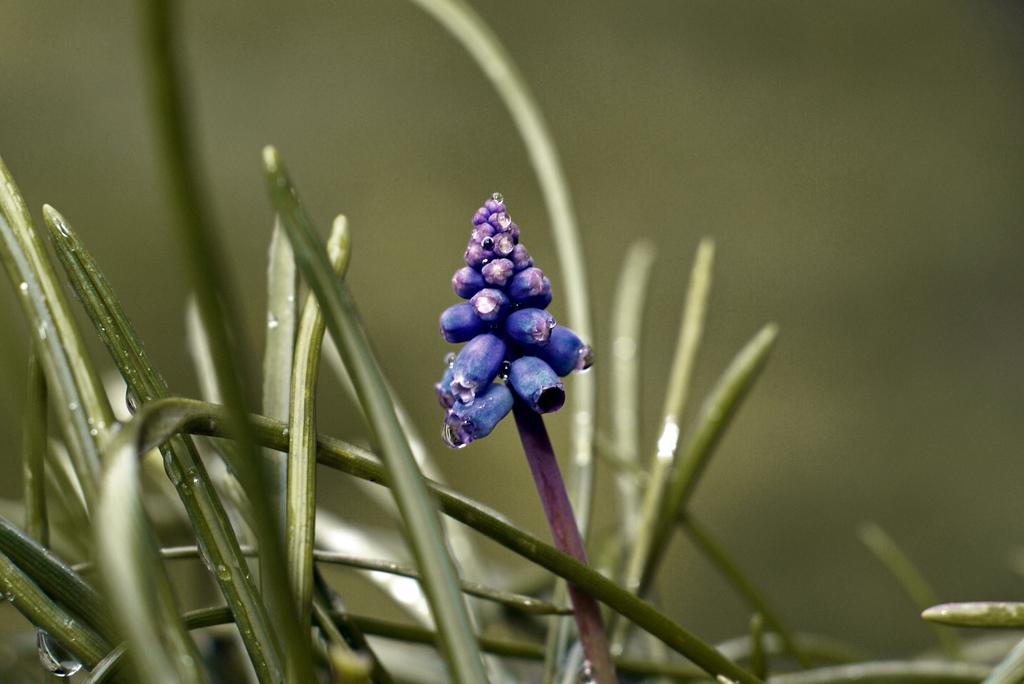What is located in the foreground of the image? There is a plant in the foreground of the image. What can be seen around the plant in the image? There are stems around the plant in the image. What type of brass instrument can be seen in the image? There is no brass instrument present in the image; it features a plant with stems. 